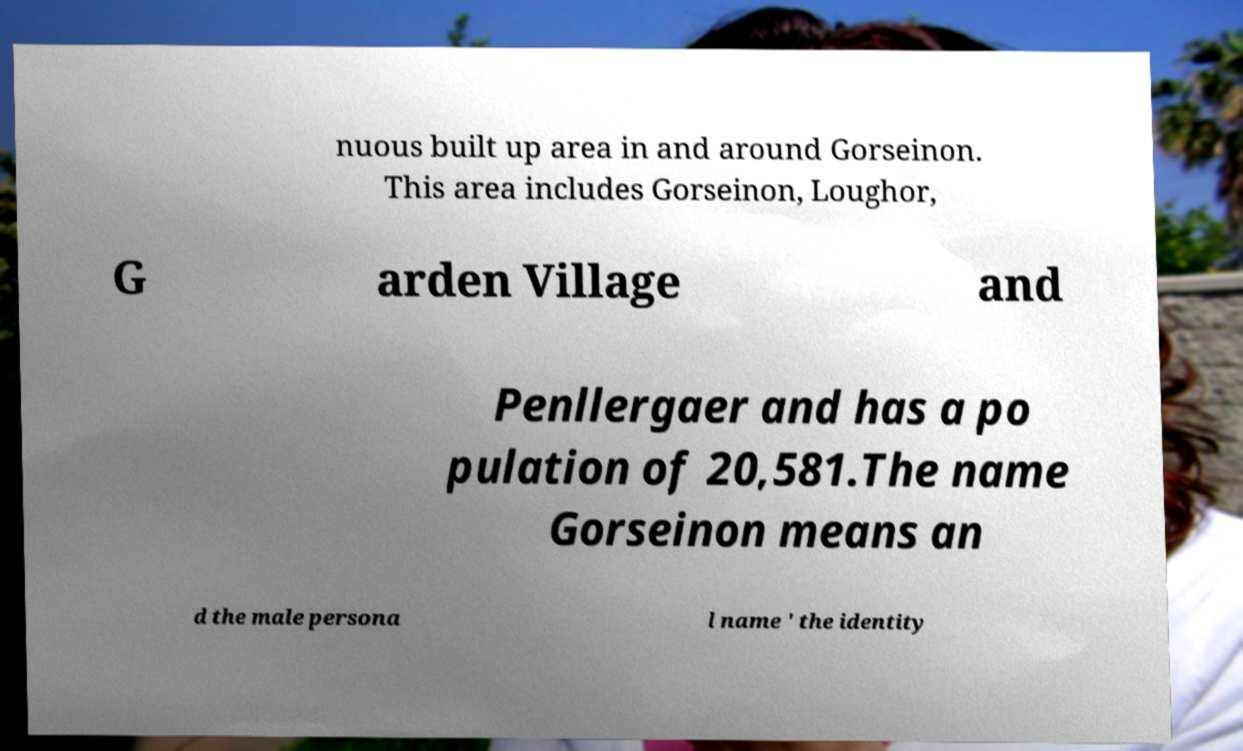Could you extract and type out the text from this image? nuous built up area in and around Gorseinon. This area includes Gorseinon, Loughor, G arden Village and Penllergaer and has a po pulation of 20,581.The name Gorseinon means an d the male persona l name ' the identity 